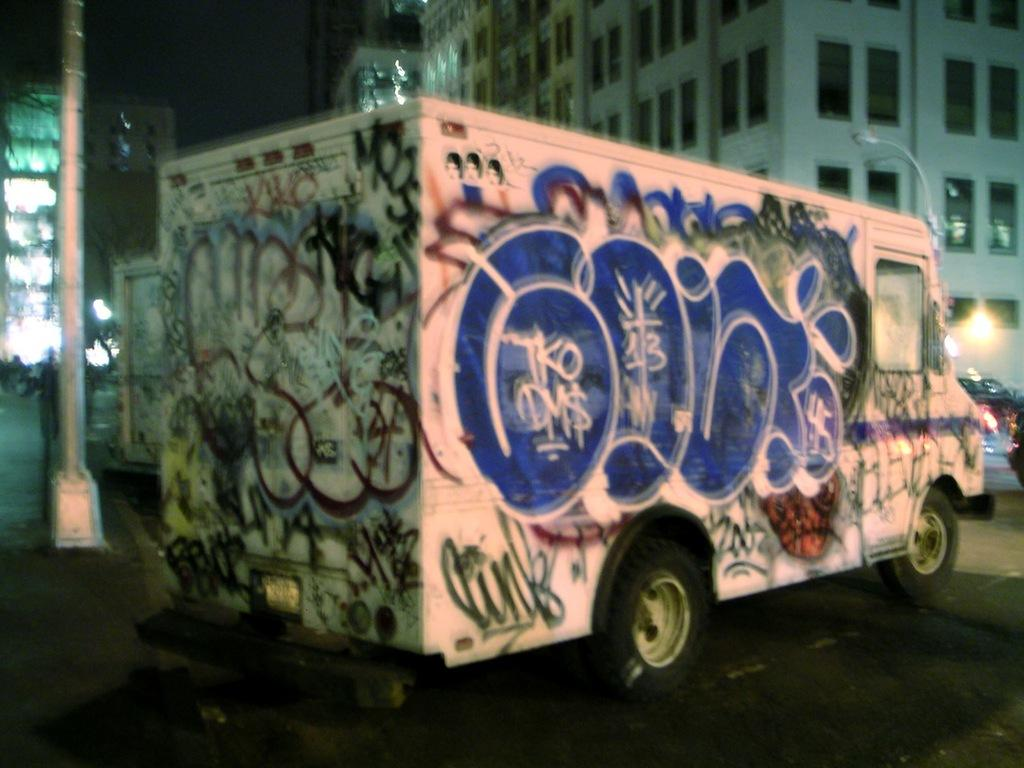What is the main subject of the image? There is a truck on the road in the image. What can be seen in the background of the image? There are buildings, poles, lights, walls, windows, vehicles, a tree, and the sky visible in the background of the image. How does the cow use its nerve to communicate with the truck in the image? There is no cow present in the image, so it is not possible to answer that question. 